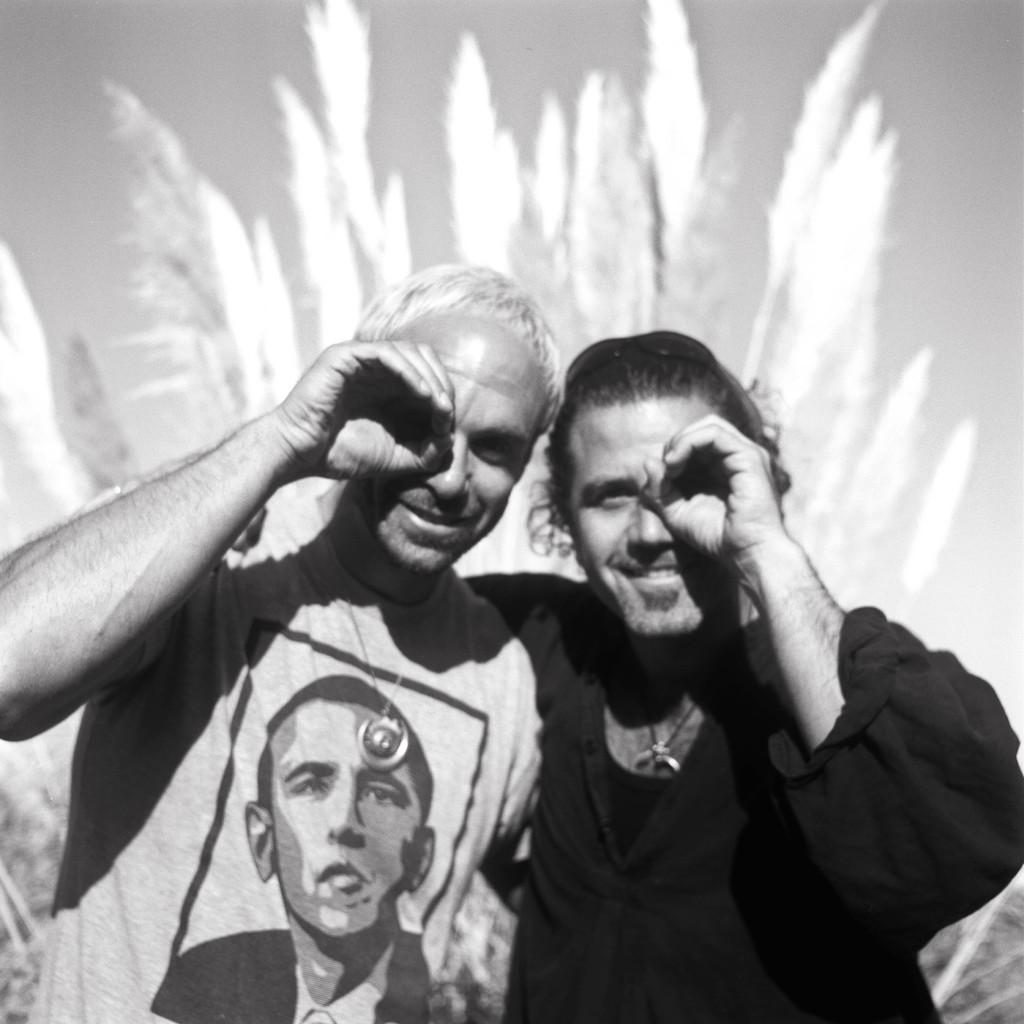What is the color scheme of the image? The image is black and white. How many people are present in the image? There are two men in the image. What can be seen in the background of the image? There are plants in the background of the image. What type of game are the two men playing in the image? There is no game visible in the image; it only features two men and plants in the background. What color is the shirt worn by one of the men in the image? The image is black and white, so it is not possible to determine the color of the shirt worn by one of the men. 